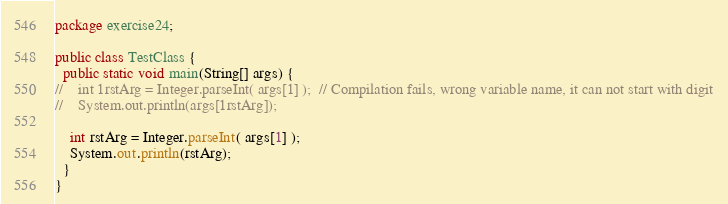<code> <loc_0><loc_0><loc_500><loc_500><_Java_>package exercise24;

public class TestClass {
  public static void main(String[] args) {
//    int 1rstArg = Integer.parseInt( args[1] );  // Compilation fails, wrong variable name, it can not start with digit
//    System.out.println(args[1rstArg]);

    int rstArg = Integer.parseInt( args[1] );
    System.out.println(rstArg);
  }
}
</code> 